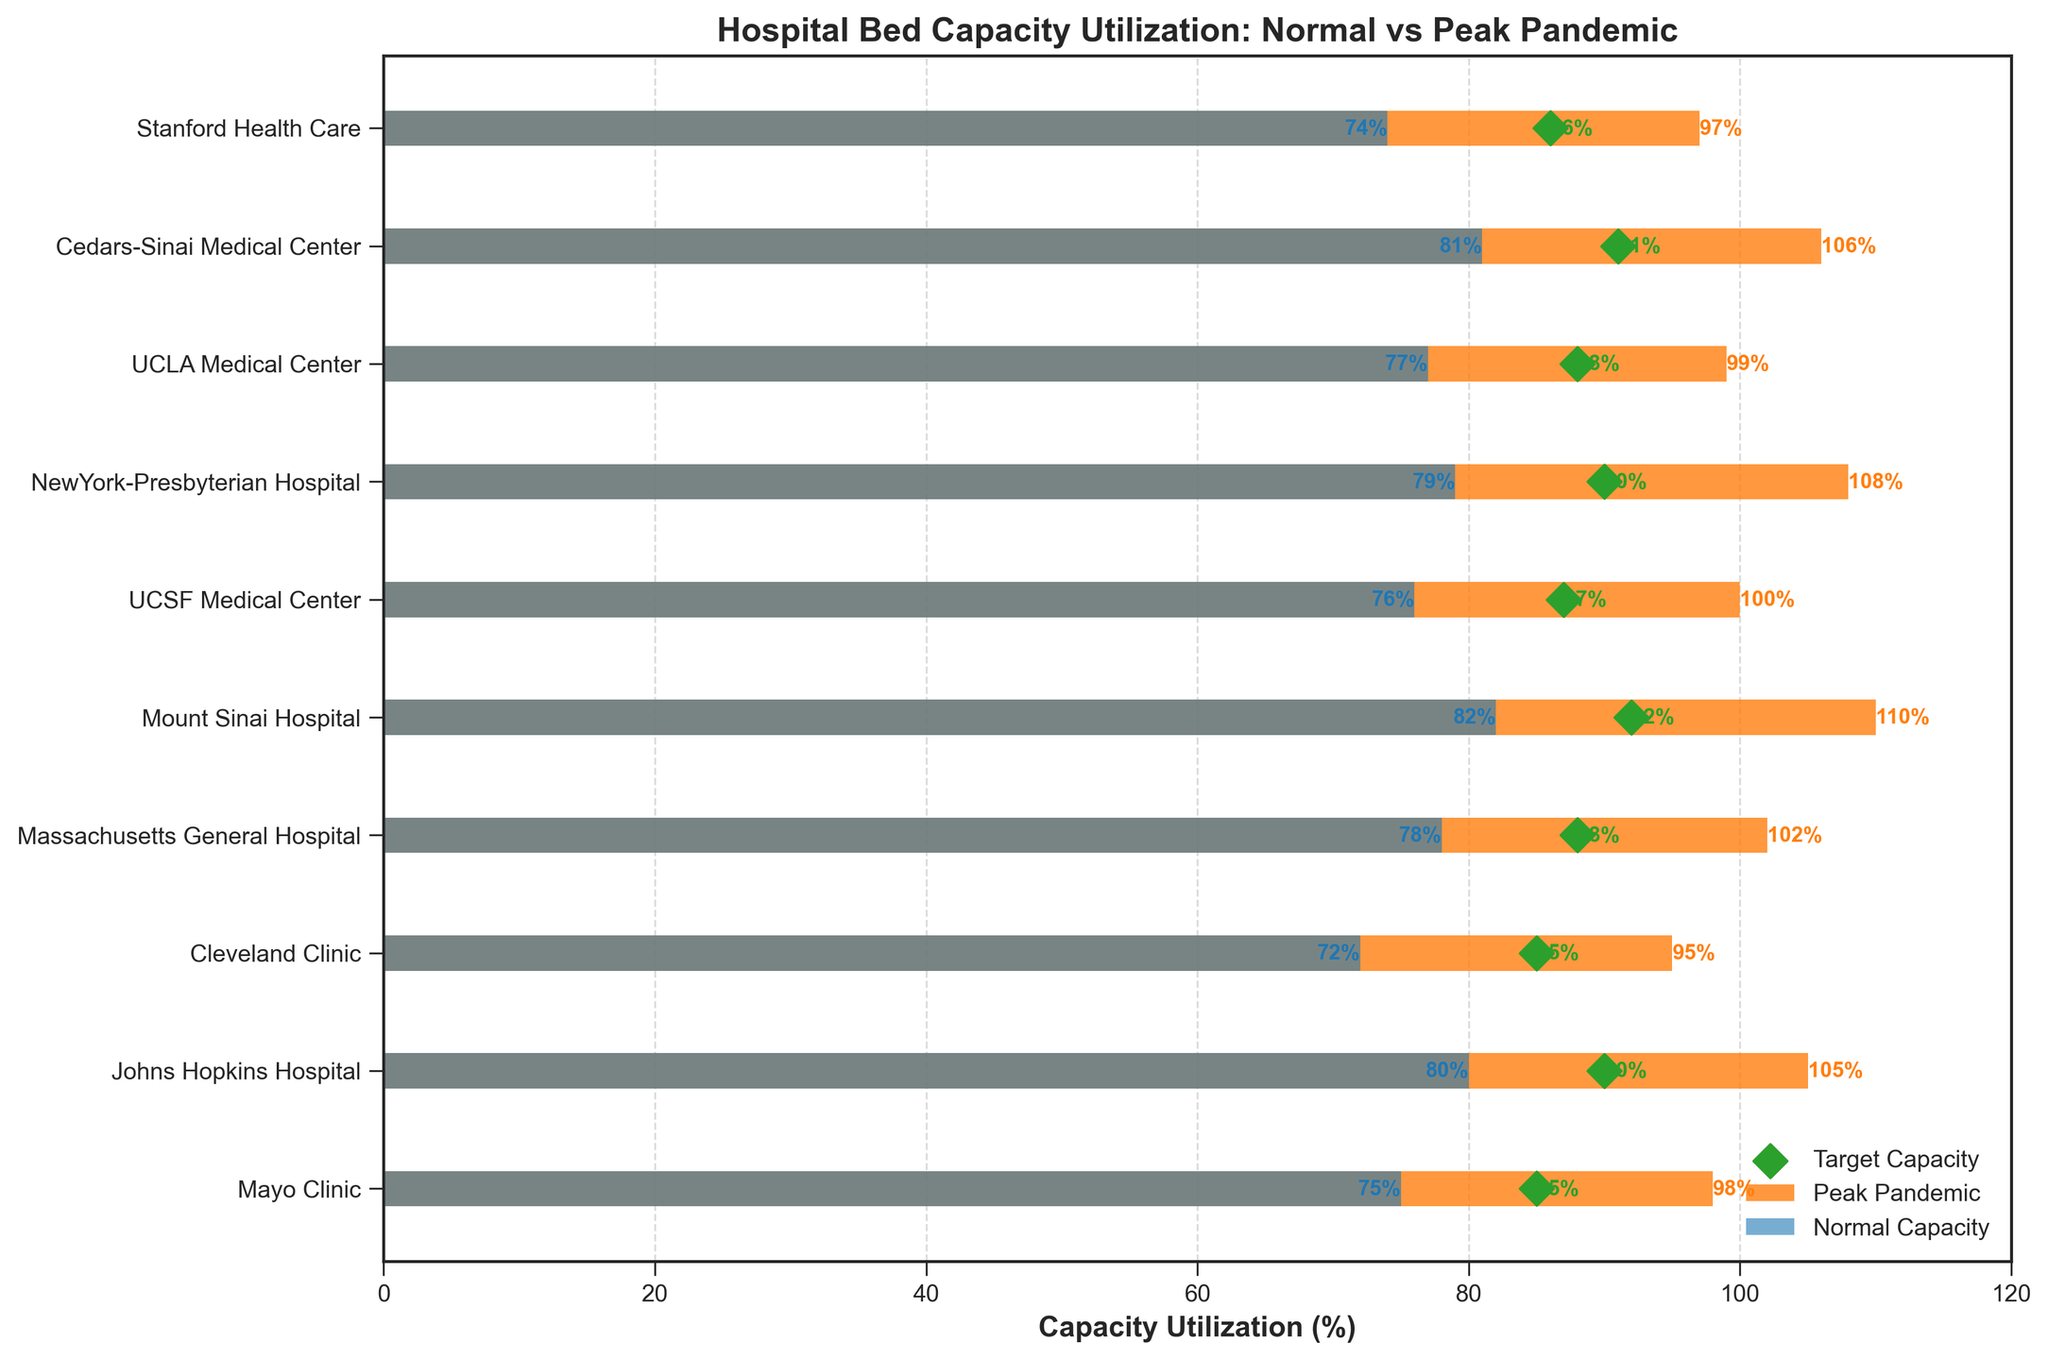How many hospitals have their peak pandemic capacity exceeding 100%? By observing the orange bars representing "Peak Pandemic" values, count the number of hospitals where this bar exceeds the 100% mark on the x-axis. Mayo Clinic, Johns Hopkins Hospital, Massachusetts General Hospital, Mount Sinai Hospital, UCSF Medical Center, NewYork-Presbyterian Hospital, Cedars-Sinai Medical Center all exceed 100%.
Answer: 7 Which hospital has the highest peak pandemic capacity utilization? Identify the hospital with the highest value of the orange bar indicating "Peak Pandemic," which is Mount Sinai Hospital at 110%.
Answer: Mount Sinai Hospital What is the difference between normal capacity and peak pandemic capacity at UCLA Medical Center? Look at the blue bar for normal capacity and the orange bar for peak pandemic capacity of UCLA Medical Center. The normal capacity is 77% and the peak pandemic capacity is 99%. Calculate the difference: 99% - 77% = 22%.
Answer: 22% Which hospital meets its target capacity utilization during peak pandemic times? Compare the orange bar for "Peak Pandemic" with the green diamond representing the "Target Capacity" across all hospitals. None of the hospitals' peak pandemic capacities fall below their target capacities.
Answer: None What is the average normal capacity utilization across all hospitals? Sum the normal capacities of all hospitals: (75 + 80 + 72 + 78 + 82 + 76 + 79 + 77 + 81 + 74) = 774. Divide by the number of hospitals (10): 774 / 10 = 77.4%.
Answer: 77.4% By how much does Johns Hopkins Hospital's peak pandemic capacity utilization exceed its target capacity? Look at the orange bar for peak pandemic capacity and the green diamond for target capacity. For Johns Hopkins Hospital, peak pandemic is 105% and target is 90%. Calculate the difference: 105% - 90% = 15%.
Answer: 15% What is the title of the chart? Refer to the text at the top of the chart. It states "Hospital Bed Capacity Utilization: Normal vs Peak Pandemic."
Answer: Hospital Bed Capacity Utilization: Normal vs Peak Pandemic Which two hospitals have the closest peak pandemic capacities? Compare the orange bars of all hospitals. UCSF Medical Center (100%) and Mayo Clinic (98%) have the closest peak pandemic capacities within a difference of 2%.
Answer: UCSF Medical Center and Mayo Clinic How does Cedars-Sinai Medical Center's normal capacity compare to its target capacity? Look at the blue bar for normal capacity and the green diamond for target capacity of Cedars-Sinai Medical Center. The normal capacity is 81% and the target capacity is 91%.
Answer: 81% is below 91% 